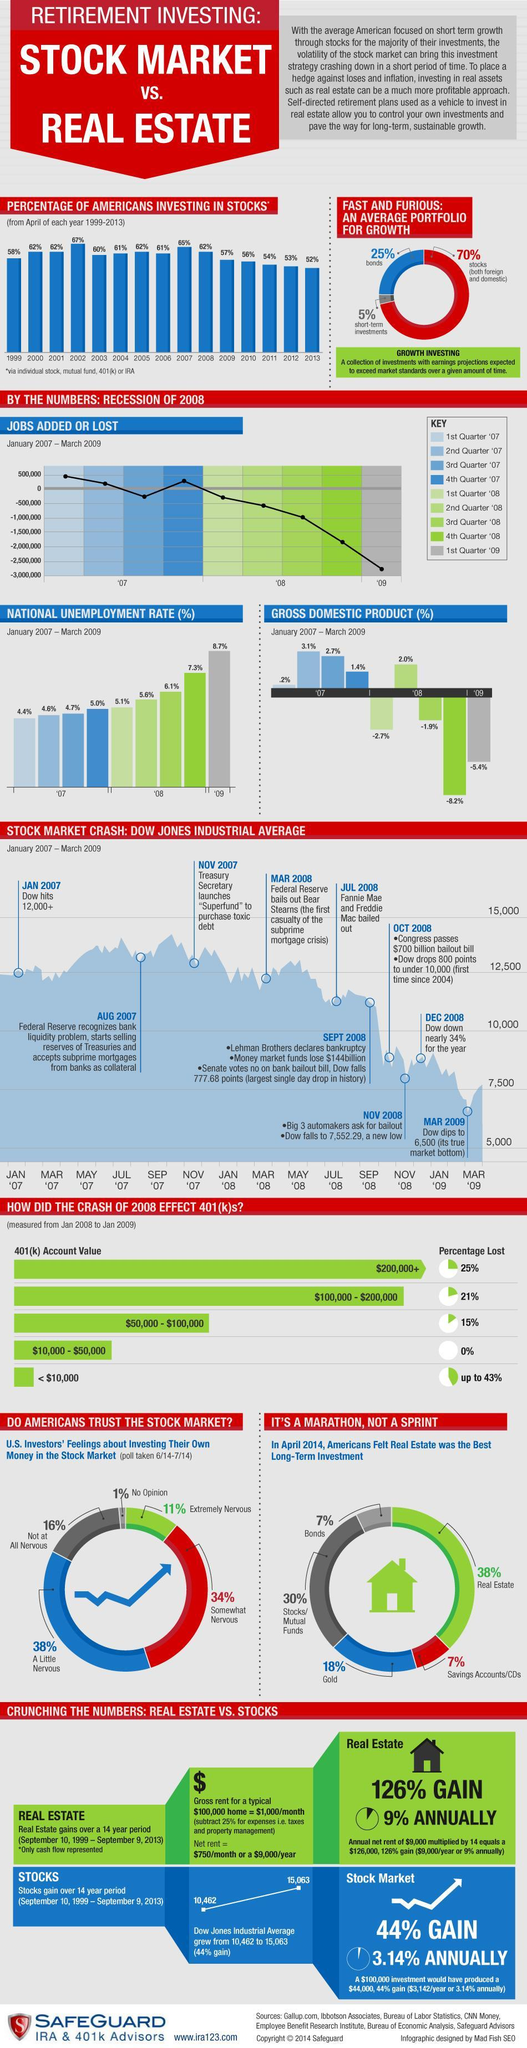What was the percentage difference in the Americans who invested in stocks in the year 2002 and 2013?
Answer the question with a short phrase. 15% Which quarter shows that 1,000,000 jobs lost? 3rd Quarter '08 When did Dow fall to a value of 7552.29, Mar 2009, Sept 2008, or Nov 2008?   ? Nov 2008 What is total percentage of Americans who are nervous about investing in the stock market? 83% Which year recorded the second lowest percentage of investment in stocks by Americans? 2012 What is the total percentage of Americans who want to invest in stocks and bonds? 37% By how much percentage has the unemployment rate grown since the 4th quarter '08 ? 1.4% Which years did 61% of Americans invest in stocks? 2004, 2006 Which quarters show that jobs were added? 1st Quarter '07, 2nd Quarter '07, 4th Quarter '07 